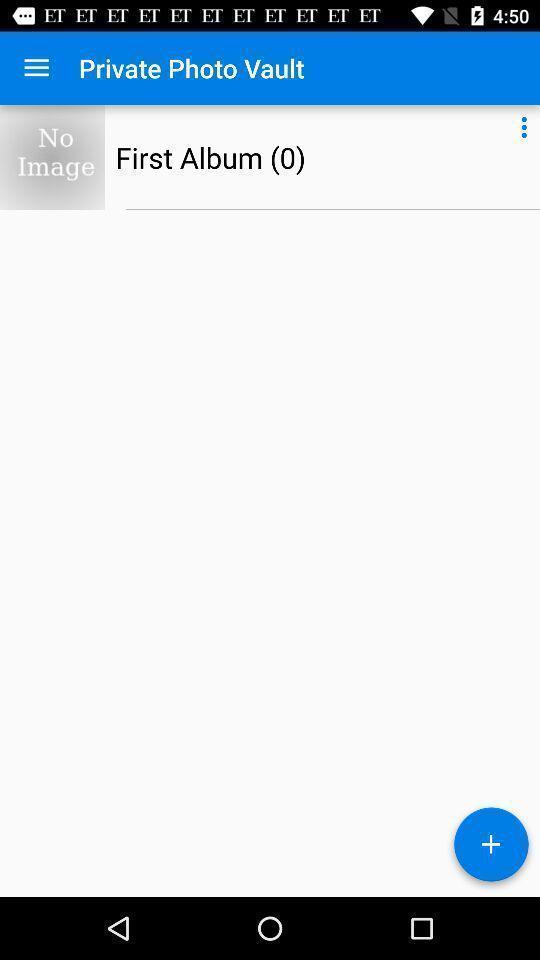Please provide a description for this image. Screen showing first album option. 